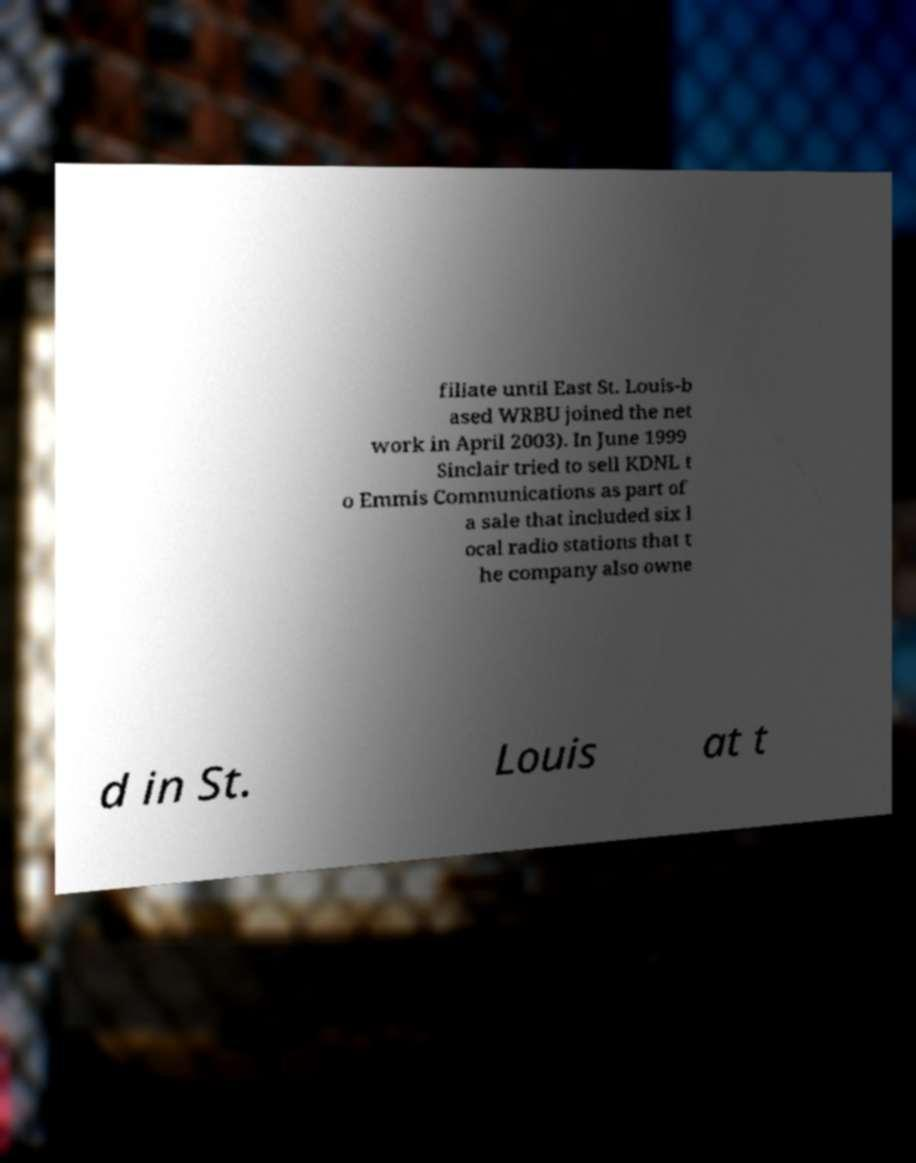I need the written content from this picture converted into text. Can you do that? filiate until East St. Louis-b ased WRBU joined the net work in April 2003). In June 1999 Sinclair tried to sell KDNL t o Emmis Communications as part of a sale that included six l ocal radio stations that t he company also owne d in St. Louis at t 